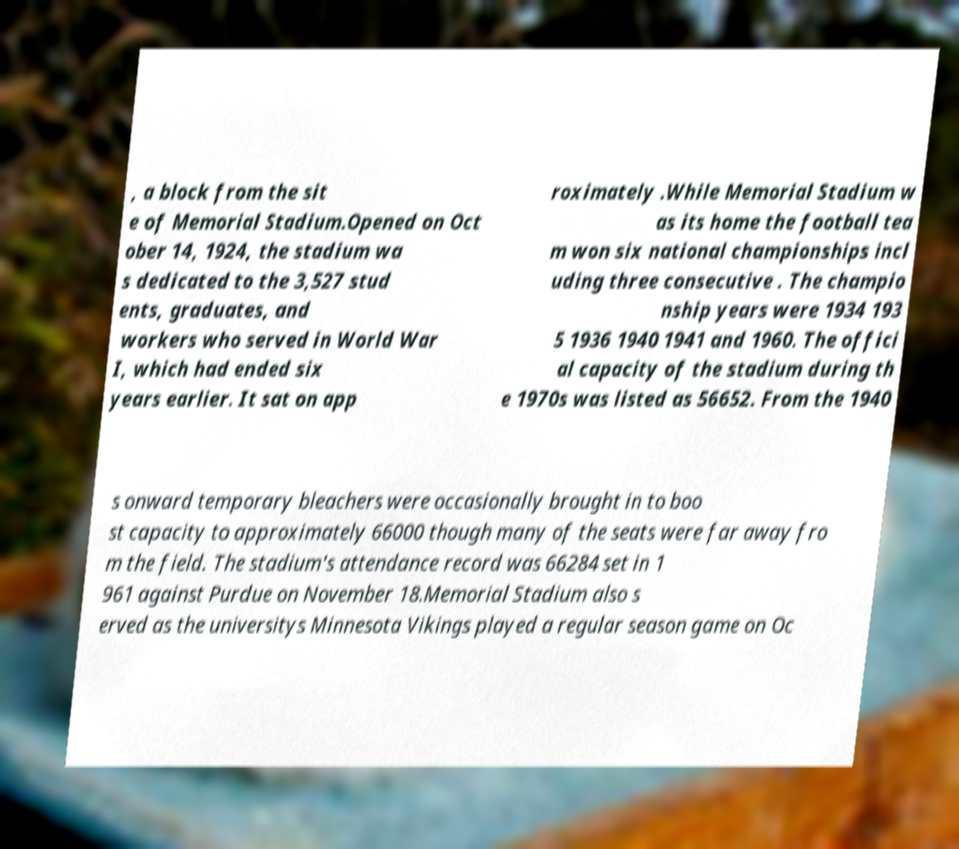Please read and relay the text visible in this image. What does it say? , a block from the sit e of Memorial Stadium.Opened on Oct ober 14, 1924, the stadium wa s dedicated to the 3,527 stud ents, graduates, and workers who served in World War I, which had ended six years earlier. It sat on app roximately .While Memorial Stadium w as its home the football tea m won six national championships incl uding three consecutive . The champio nship years were 1934 193 5 1936 1940 1941 and 1960. The offici al capacity of the stadium during th e 1970s was listed as 56652. From the 1940 s onward temporary bleachers were occasionally brought in to boo st capacity to approximately 66000 though many of the seats were far away fro m the field. The stadium's attendance record was 66284 set in 1 961 against Purdue on November 18.Memorial Stadium also s erved as the universitys Minnesota Vikings played a regular season game on Oc 